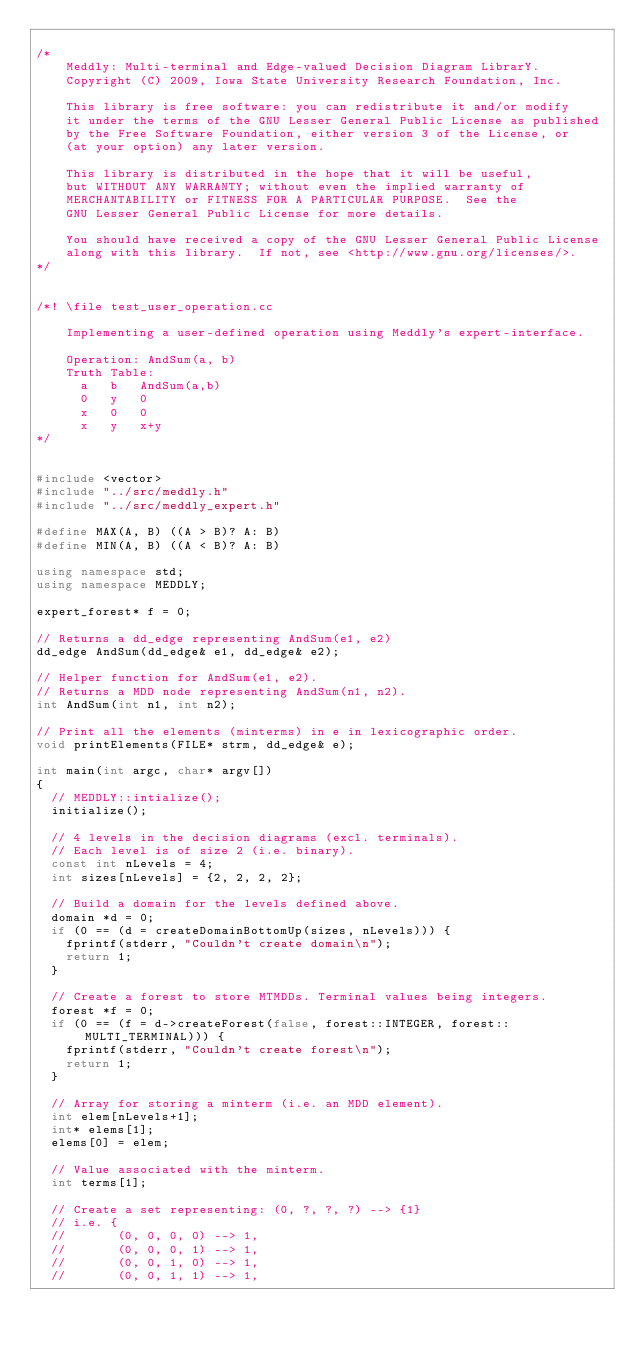Convert code to text. <code><loc_0><loc_0><loc_500><loc_500><_C++_>
/*
    Meddly: Multi-terminal and Edge-valued Decision Diagram LibrarY.
    Copyright (C) 2009, Iowa State University Research Foundation, Inc.

    This library is free software: you can redistribute it and/or modify
    it under the terms of the GNU Lesser General Public License as published 
    by the Free Software Foundation, either version 3 of the License, or
    (at your option) any later version.

    This library is distributed in the hope that it will be useful,
    but WITHOUT ANY WARRANTY; without even the implied warranty of
    MERCHANTABILITY or FITNESS FOR A PARTICULAR PURPOSE.  See the
    GNU Lesser General Public License for more details.

    You should have received a copy of the GNU Lesser General Public License
    along with this library.  If not, see <http://www.gnu.org/licenses/>.
*/


/*! \file test_user_operation.cc
    
    Implementing a user-defined operation using Meddly's expert-interface.

    Operation: AndSum(a, b)
    Truth Table:
      a   b   AndSum(a,b)
      0   y   0
      x   0   0
      x   y   x+y
*/


#include <vector>
#include "../src/meddly.h"
#include "../src/meddly_expert.h"

#define MAX(A, B) ((A > B)? A: B)
#define MIN(A, B) ((A < B)? A: B)

using namespace std;
using namespace MEDDLY;

expert_forest* f = 0;

// Returns a dd_edge representing AndSum(e1, e2)
dd_edge AndSum(dd_edge& e1, dd_edge& e2);

// Helper function for AndSum(e1, e2).
// Returns a MDD node representing AndSum(n1, n2).
int AndSum(int n1, int n2);

// Print all the elements (minterms) in e in lexicographic order.
void printElements(FILE* strm, dd_edge& e);

int main(int argc, char* argv[])
{
  // MEDDLY::intialize();
  initialize();

  // 4 levels in the decision diagrams (excl. terminals).
  // Each level is of size 2 (i.e. binary).
  const int nLevels = 4;
  int sizes[nLevels] = {2, 2, 2, 2};

  // Build a domain for the levels defined above.
  domain *d = 0;
  if (0 == (d = createDomainBottomUp(sizes, nLevels))) {
    fprintf(stderr, "Couldn't create domain\n");
    return 1;
  }

  // Create a forest to store MTMDDs. Terminal values being integers.
  forest *f = 0;
  if (0 == (f = d->createForest(false, forest::INTEGER, forest::MULTI_TERMINAL))) {
    fprintf(stderr, "Couldn't create forest\n");
    return 1;
  }

  // Array for storing a minterm (i.e. an MDD element).
  int elem[nLevels+1];
  int* elems[1];
  elems[0] = elem;

  // Value associated with the minterm.
  int terms[1];

  // Create a set representing: (0, ?, ?, ?) --> {1}
  // i.e. {
  //       (0, 0, 0, 0) --> 1,
  //       (0, 0, 0, 1) --> 1,
  //       (0, 0, 1, 0) --> 1,
  //       (0, 0, 1, 1) --> 1,</code> 